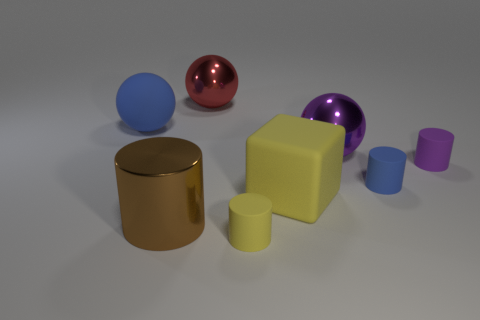What shape is the rubber object that is the same color as the big rubber sphere?
Your response must be concise. Cylinder. The object that is the same color as the block is what size?
Offer a terse response. Small. How many other objects are there of the same shape as the small yellow rubber object?
Give a very brief answer. 3. What shape is the small thing that is behind the blue matte object that is on the right side of the blue matte object on the left side of the tiny blue matte cylinder?
Ensure brevity in your answer.  Cylinder. How many things are either big brown cylinders or shiny balls behind the big blue matte thing?
Ensure brevity in your answer.  2. Is the shape of the yellow object that is behind the tiny yellow rubber object the same as the big object that is behind the matte ball?
Your response must be concise. No. What number of objects are tiny purple things or small cylinders?
Ensure brevity in your answer.  3. Is there anything else that has the same material as the blue sphere?
Ensure brevity in your answer.  Yes. Is there a large yellow matte ball?
Your response must be concise. No. Is the material of the blue object that is on the left side of the large purple metal ball the same as the block?
Give a very brief answer. Yes. 